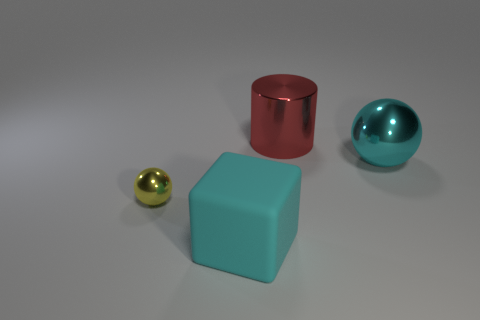Add 1 small gray metal blocks. How many objects exist? 5 Subtract all cylinders. How many objects are left? 3 Add 4 big red cylinders. How many big red cylinders are left? 5 Add 1 tiny brown matte balls. How many tiny brown matte balls exist? 1 Subtract 0 gray balls. How many objects are left? 4 Subtract all yellow shiny things. Subtract all tiny metallic cubes. How many objects are left? 3 